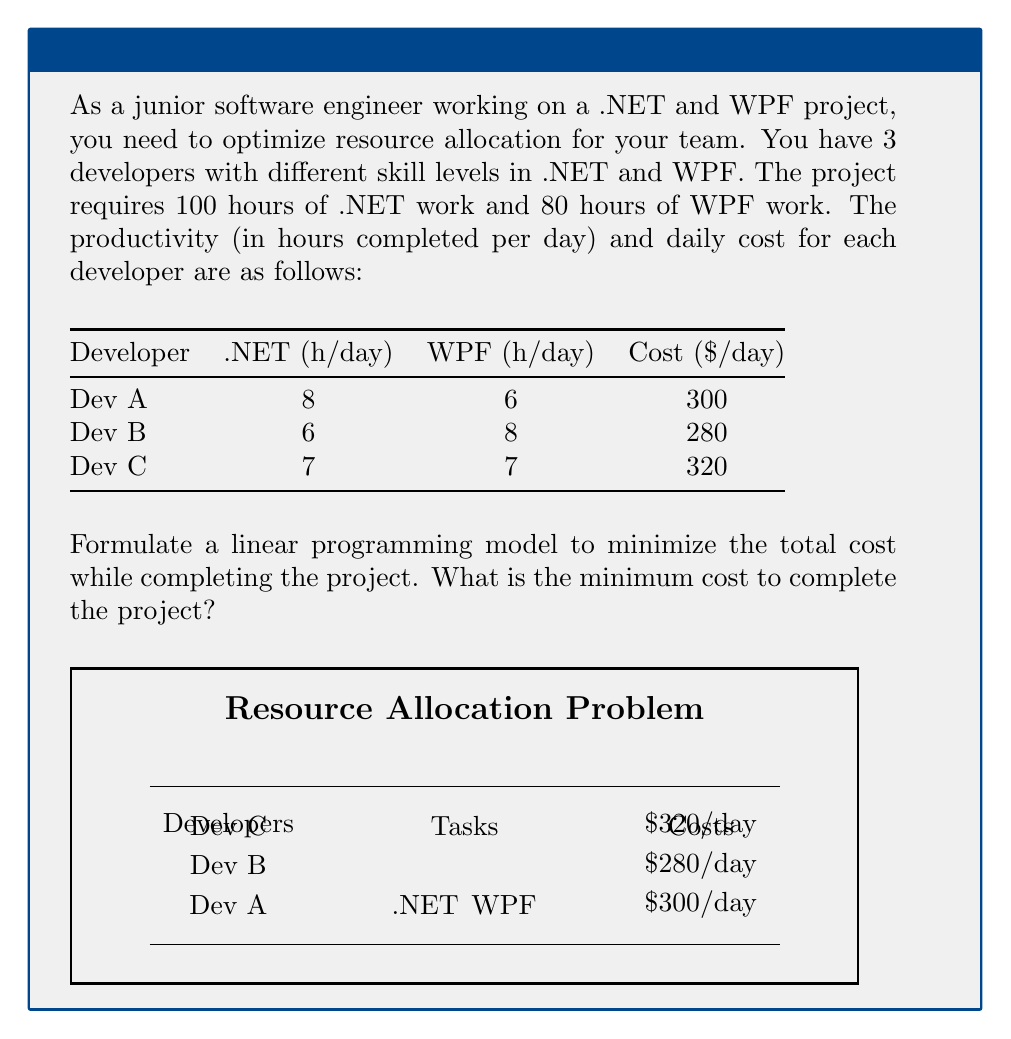Teach me how to tackle this problem. Let's solve this step-by-step using linear programming:

1. Define variables:
   Let $x_A$, $x_B$, and $x_C$ be the number of days assigned to Dev A, B, and C respectively.

2. Objective function (minimize total cost):
   $$\text{Minimize } Z = 300x_A + 280x_B + 320x_C$$

3. Constraints:
   a) .NET work constraint:
      $$8x_A + 6x_B + 7x_C \geq 100$$
   
   b) WPF work constraint:
      $$6x_A + 8x_B + 7x_C \geq 80$$
   
   c) Non-negativity constraints:
      $$x_A, x_B, x_C \geq 0$$

4. Solve using a linear programming solver (e.g., simplex method):
   The optimal solution is:
   $x_A \approx 5.71$ days
   $x_B \approx 6.43$ days
   $x_C = 0$ days

5. Calculate the minimum cost:
   $$Z = 300(5.71) + 280(6.43) + 320(0) \approx 3513.40$$

Therefore, the minimum cost to complete the project is approximately $3,513.40.
Answer: $3,513.40 